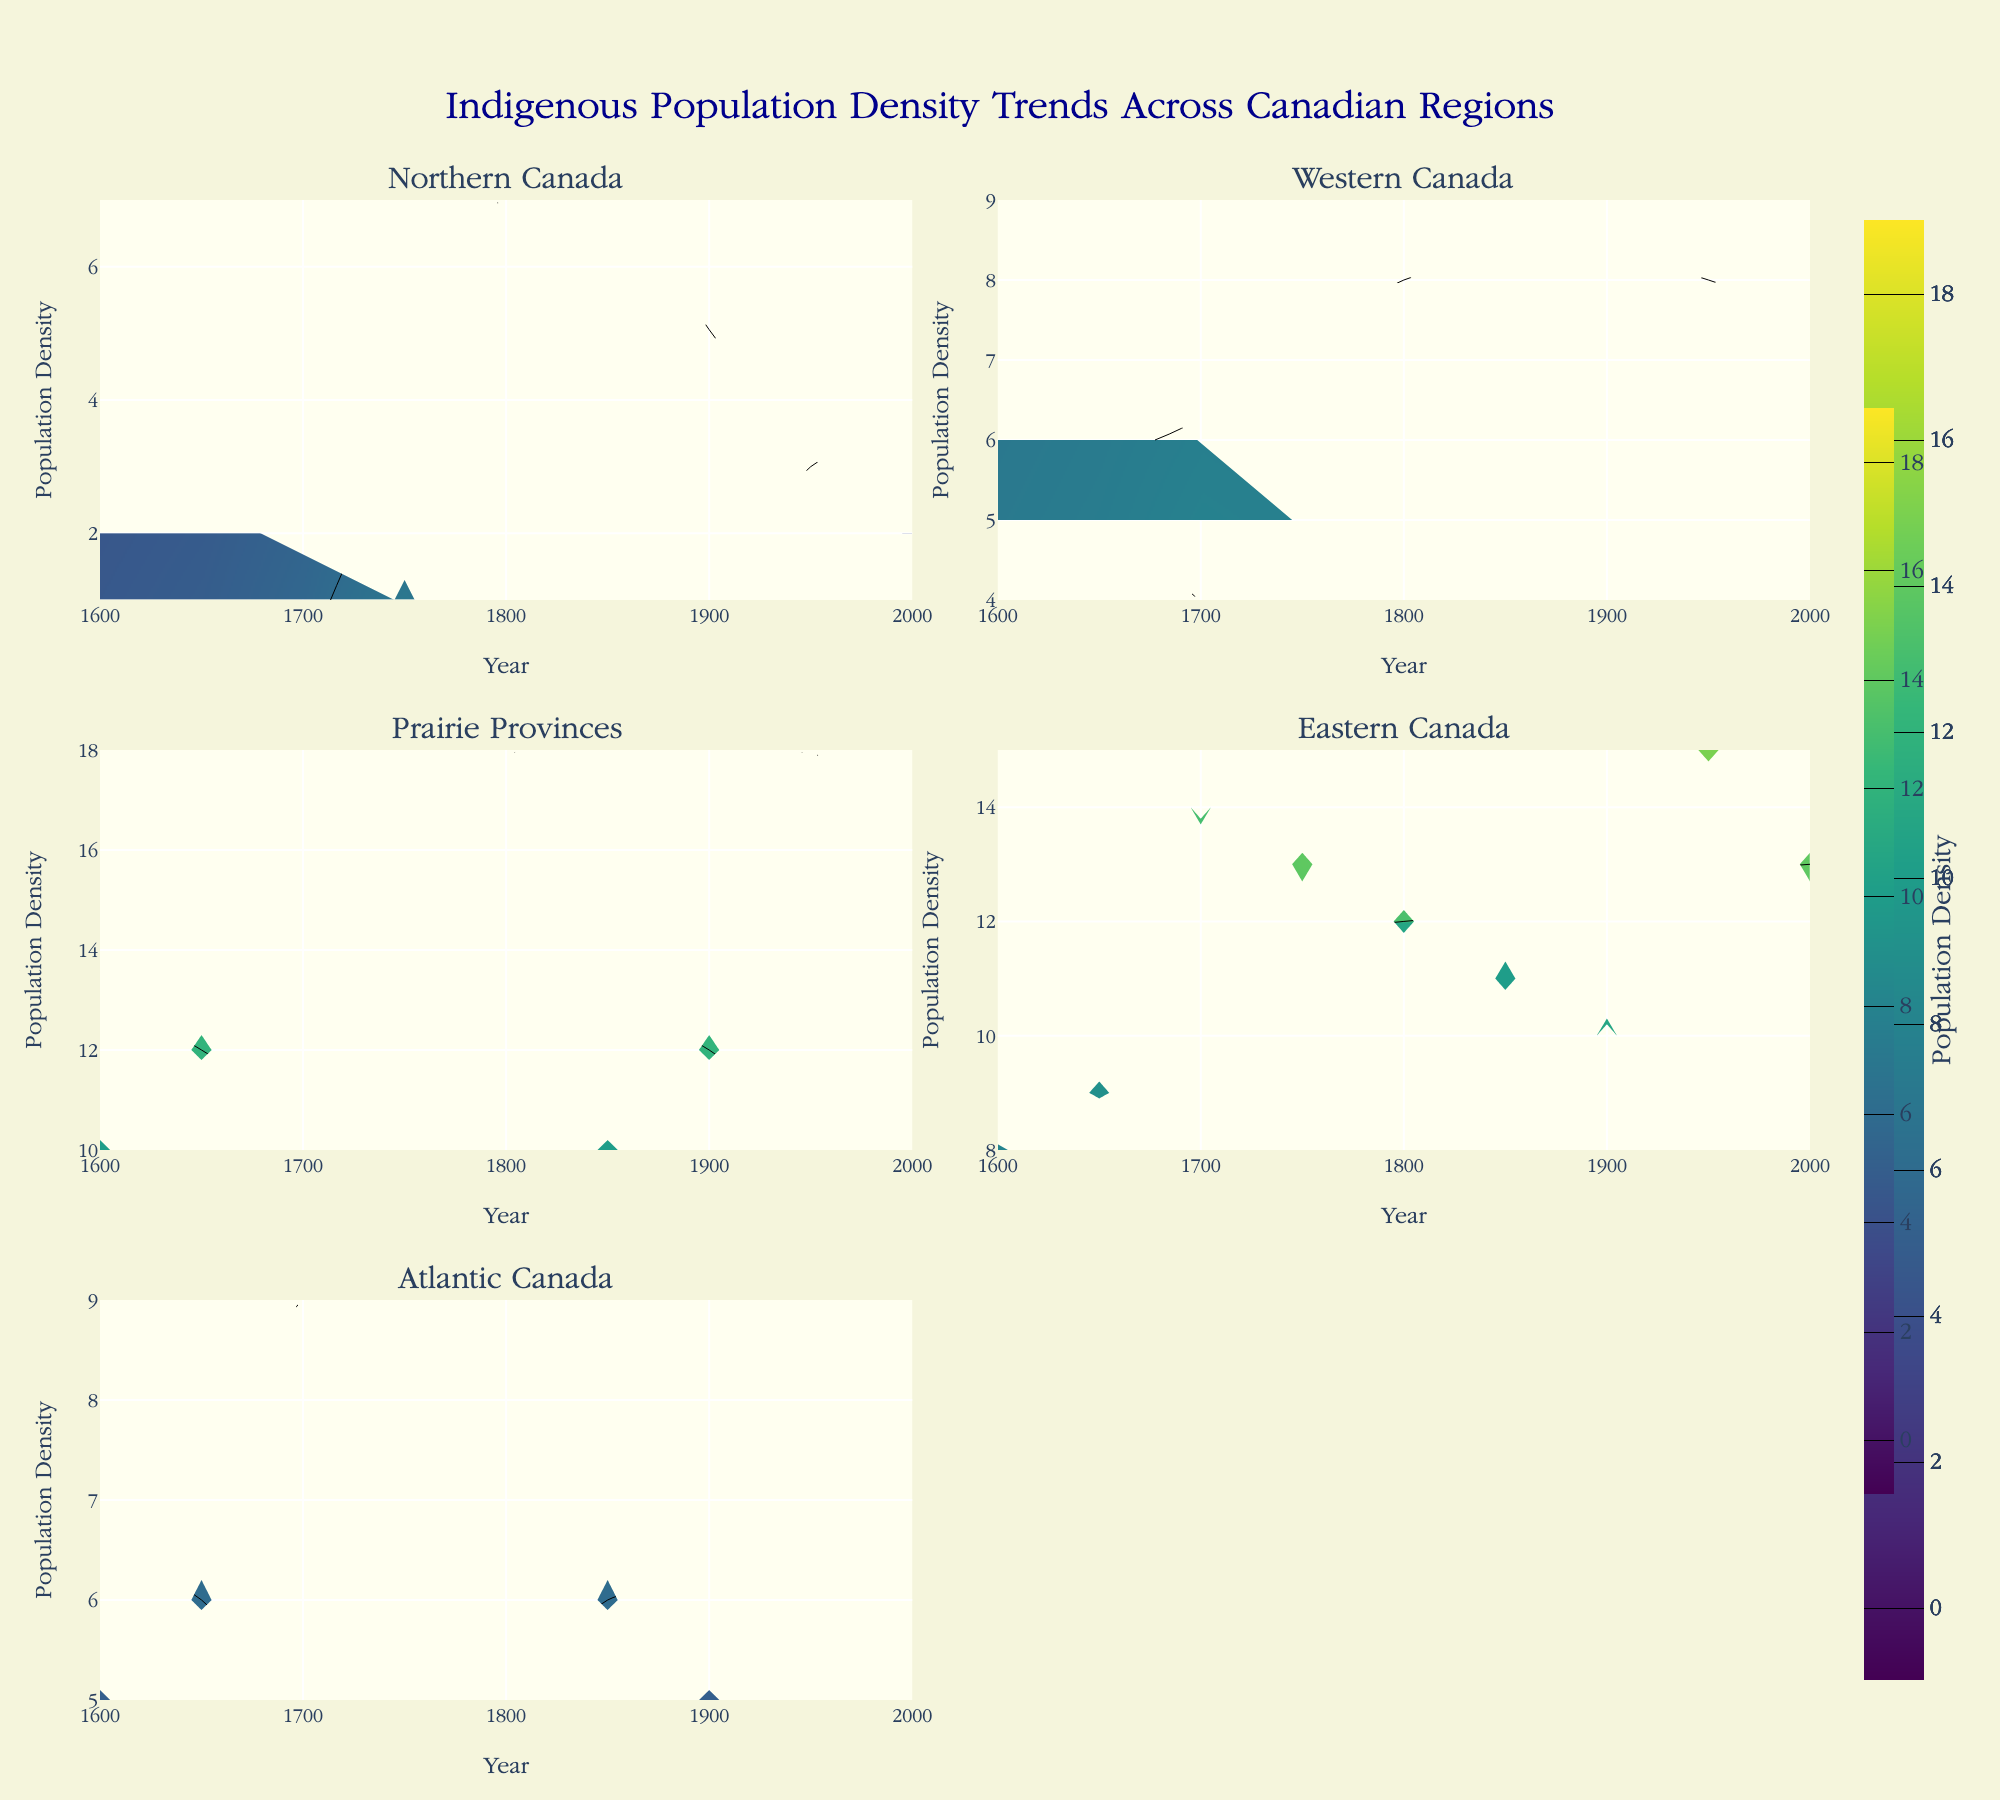What's the title of the figure? The title is displayed at the top center of the figure and reads, "Indigenous Population Density Trends Across Canadian Regions."
Answer: Indigenous Population Density Trends Across Canadian Regions Which region shows a decrease in population density from 1750 to 1800? By observing the contour lines and colors for the period from 1750 to 1800, Northern Canada shows a notable decrease, changing from a density of 7 to 4.
Answer: Northern Canada What is the highest population density reached in the Prairie Provinces throughout the periods studied? The contour lines and color bar indicate that the Prairie Provinces reach their highest density at 18 in the year 1750.
Answer: 18 Between Western Canada and Eastern Canada, which has a higher population density in 1900? Comparing the contour lines and colors for the year 1900 between Western Canada and Eastern Canada, Eastern Canada has a density of 13, whereas Western Canada has 5. Thus, Eastern Canada is higher.
Answer: Eastern Canada How does the population density in Atlantic Canada change from 1600 to 1950? Observing the contour lines and colors in Atlantic Canada, the density starts at 5 in 1600, increases gradually, reaching 7 in 1950.
Answer: Increases from 5 to 7 Which region has the most stable population density trend over time? By visually comparing the smoothness and consistency of the contour lines and colors over time, Western Canada remains relatively stable with densities between 6 and 9.
Answer: Western Canada Calculate the difference in population density for Eastern Canada between its highest and lowest points. Eastern Canada's highest population density is 15 (in 1950), and the lowest is 8 (in 1600). The difference is 15 - 8 = 7.
Answer: 7 Which region exhibits the most significant fluctuation in population density? Observing the density changes over time in each region, Northern Canada has the most significant fluctuations, alternating between 1 and 7.
Answer: Northern Canada What is the overall trend of population density in Northern Canada from 1600 to 2000? Examining the contour lines, Northern Canada's population density rises from 2 in 1600 to a peak of 7 in 1750 and then declines steadily to 1 in 2000.
Answer: Rises then declines 